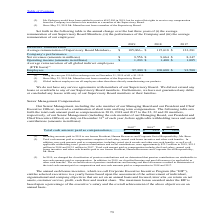According to Stmicroelectronics's financial document, What was the exchange rate used for EUR to USD on 31 December 2019? According to the financial document, €1 = $1.1213. The relevant text states: "er US dollar exchange rate on December 31, 2019 of €1 = $1.1213...." Also, Since when has Mr. Manzi not been a part of the supervisory board? According to the financial document, May 23, 2019. The relevant text states: "(3) Since May 23, 2019 Mr. Manzi has not been a member of the Supervisory Board...." Also, What is the comment on the status of Global indirect employees? Global indirect employees are all employees other than those directly manufacturing our products.. The document states: "(3) Global indirect employees are all employees other than those directly manufacturing our products...." Also, can you calculate: What was the increase / (decrease) in the Average remuneration of Supervisory Board Members from 2018 to 2019? Based on the calculation: 105,066 - 115,618, the result is -10552 (in millions). This is based on the information: "e remuneration of Supervisory Board Members (1) $ 105,066 (2) $ 115,618 $ 123,281 of Supervisory Board Members (1) $ 105,066 (2) $ 115,618 $ 123,281..." The key data points involved are: 105,066, 115,618. Also, can you calculate: What was the average Net Revenues? To answer this question, I need to perform calculations using the financial data. The calculation is: (9,556 + 9,664 + 8,347) / 3, which equals 9189 (in millions). This is based on the information: "revenues (amounts in millions) $ 9,556 $ 9,664 $ 8,347 Net revenues (amounts in millions) $ 9,556 $ 9,664 $ 8,347 Net revenues (amounts in millions) $ 9,556 $ 9,664 $ 8,347..." The key data points involved are: 8,347, 9,556, 9,664. Also, can you calculate: What is the percentage increase / (decrease) in Operating income from 2018 to 2019? To answer this question, I need to perform calculations using the financial data. The calculation is: 1,203 / 1,400 - 1, which equals -14.07 (percentage). This is based on the information: "Operating income (amounts in millions) $ 1,203 $ 1,400 $ 1,005 Operating income (amounts in millions) $ 1,203 $ 1,400 $ 1,005..." The key data points involved are: 1,203, 1,400. 